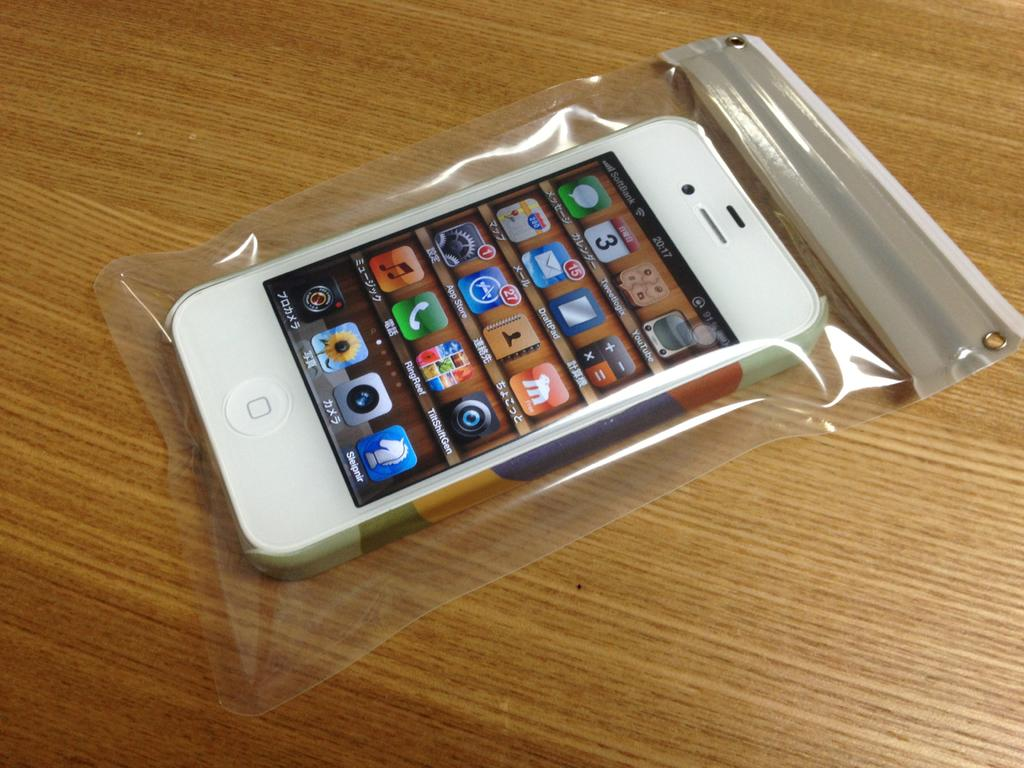<image>
Create a compact narrative representing the image presented. the word RingReef that is on an app 